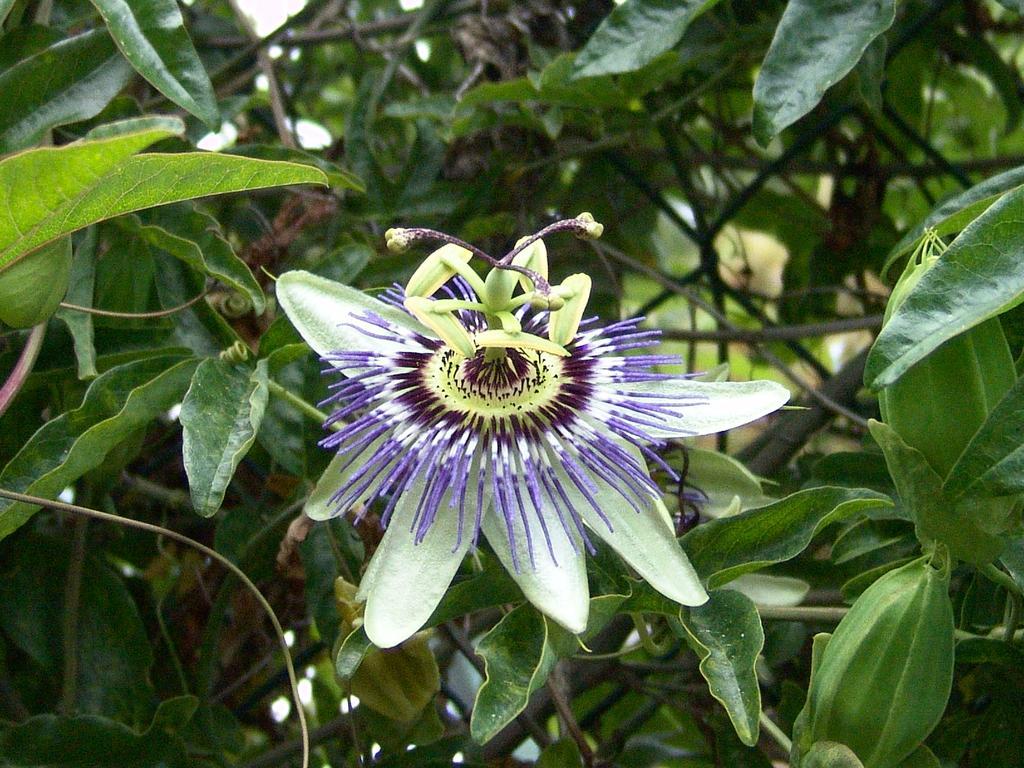In one or two sentences, can you explain what this image depicts? In this image there is a flower. In the background there are trees. 